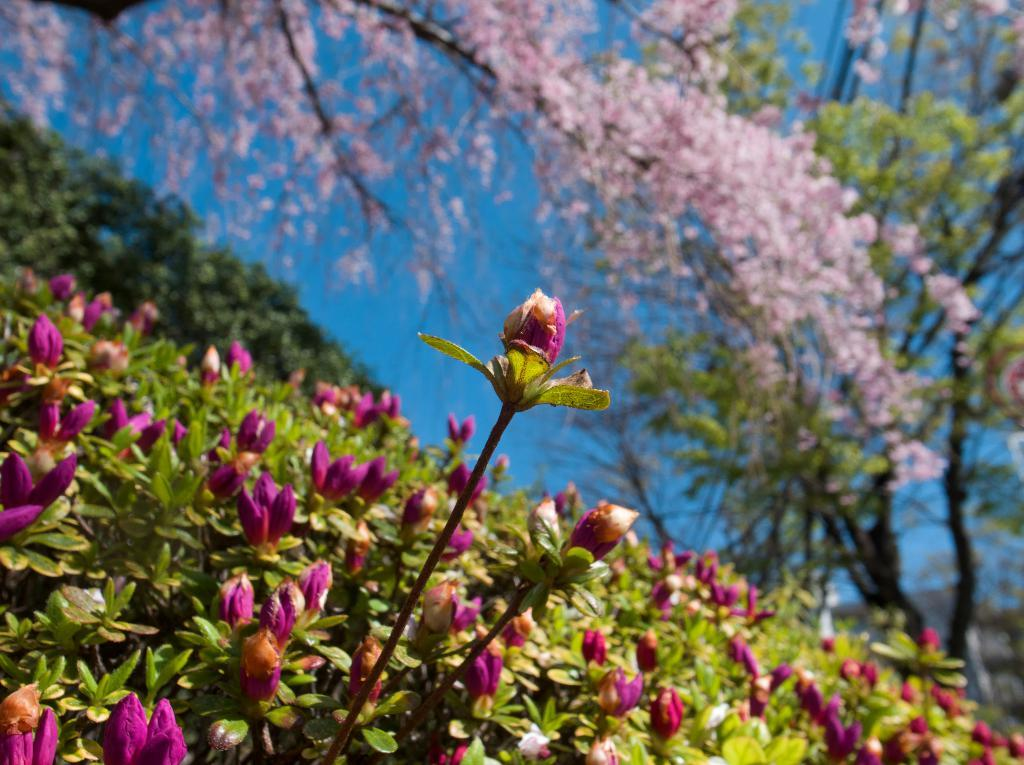Where was the image taken? The image is taken outdoors. What type of vegetation can be seen at the bottom of the image? There are plants with flowers at the bottom of the image. What can be seen in the background of the image? There are trees and the sky visible in the background of the image. What type of wall can be seen in the image? There is no wall present in the image; it is taken outdoors with plants and trees visible. 